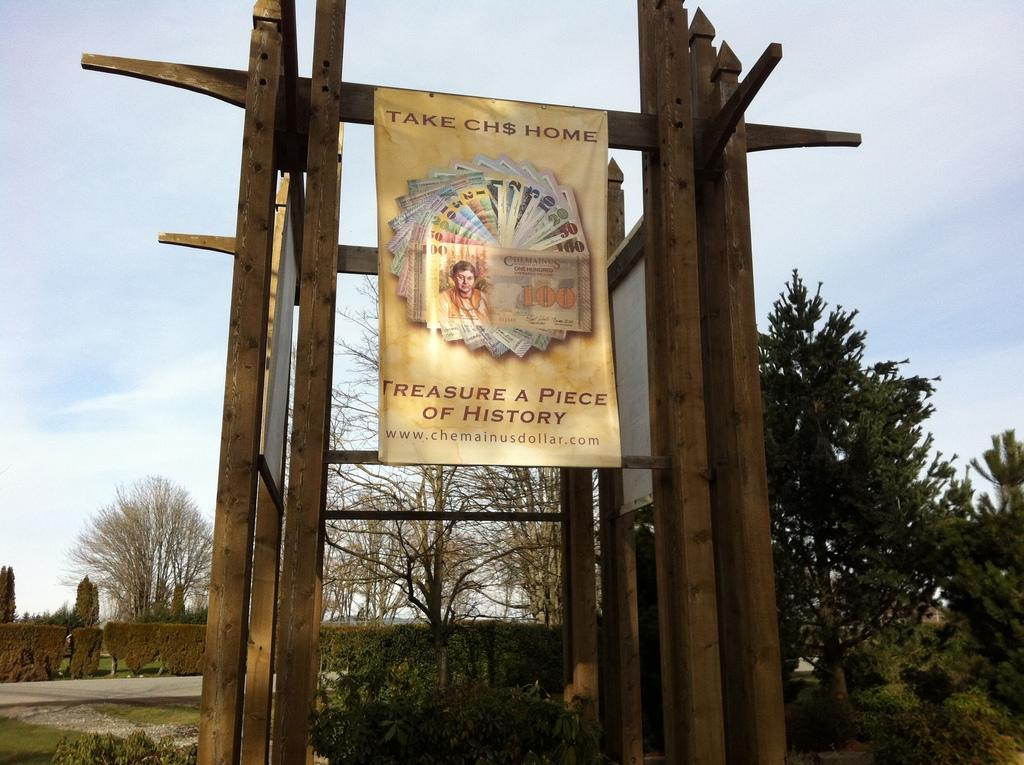What is the main subject in the center of the image? There is a poster in the center of the image. How is the poster supported or displayed? The poster is on a wooden frame. What can be seen in the background of the image? There are trees in the background of the image. What is visible above the poster in the image? The sky is visible in the image. What type of vegetation is at the bottom of the image? There are plants at the bottom of the image. What type of instrument is being played by the cherry in the image? There is no cherry or instrument present in the image. 